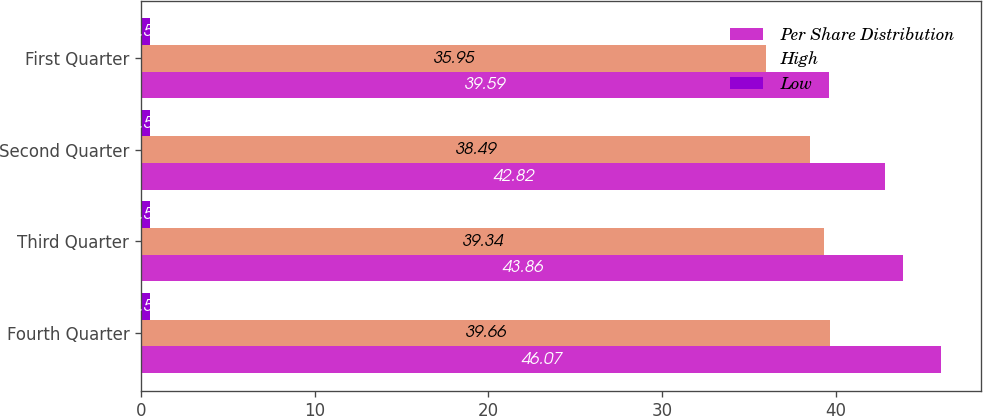<chart> <loc_0><loc_0><loc_500><loc_500><stacked_bar_chart><ecel><fcel>Fourth Quarter<fcel>Third Quarter<fcel>Second Quarter<fcel>First Quarter<nl><fcel>Per Share Distribution<fcel>46.07<fcel>43.86<fcel>42.82<fcel>39.59<nl><fcel>High<fcel>39.66<fcel>39.34<fcel>38.49<fcel>35.95<nl><fcel>Low<fcel>0.55<fcel>0.55<fcel>0.55<fcel>0.55<nl></chart> 